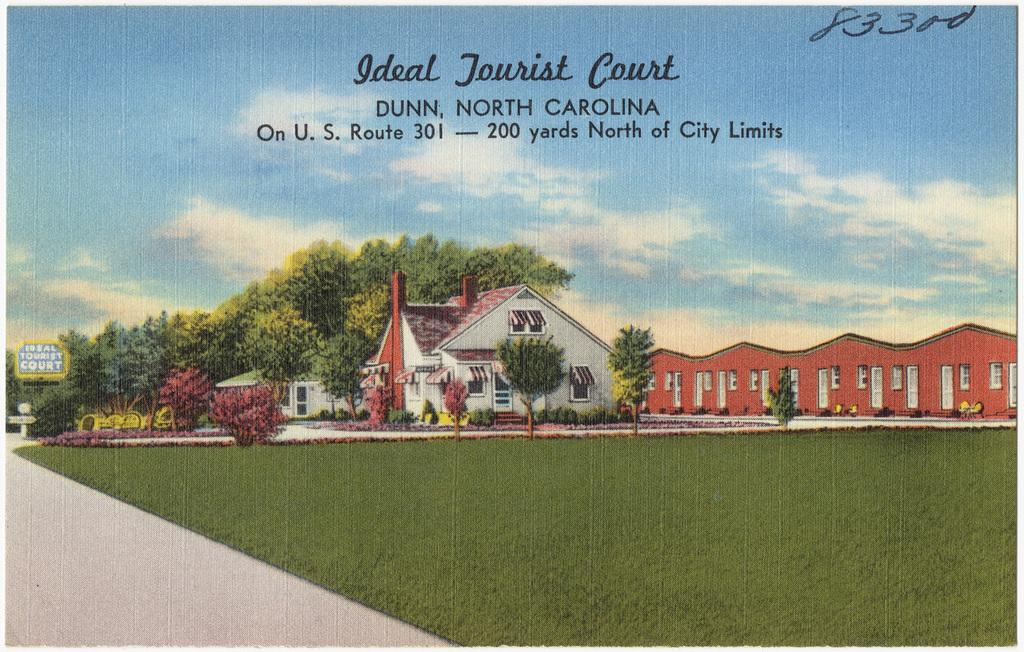What type of paintings are present in the image? The image contains paintings of houses, trees, plants, grass, a board, and the sky. Can you describe the subject matter of the paintings? The paintings depict houses, trees, plants, grass, a board, and the sky. Are there any paintings of living organisms in the image? Yes, there are paintings of trees and plants, which are living organisms. Can you tell me how many kittens are depicted in the painting of the board? There are no kittens depicted in the painting of the board; the painting only features a board. What type of ear is shown in the painting of the sky? There are no ears present in the painting of the sky; the painting only features the sky. 